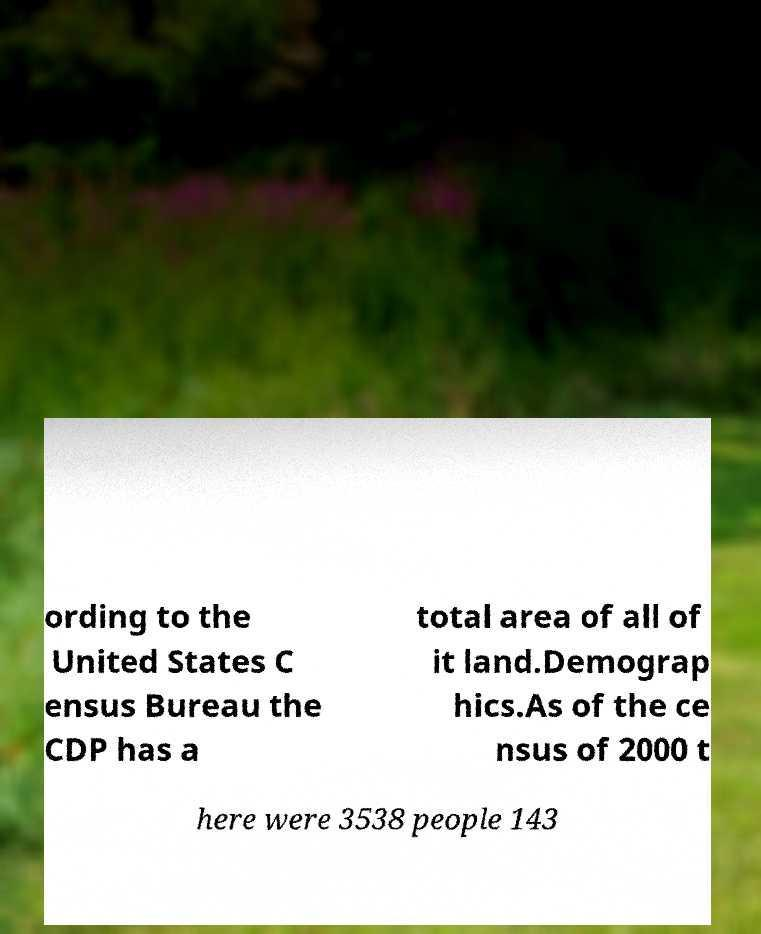Can you read and provide the text displayed in the image?This photo seems to have some interesting text. Can you extract and type it out for me? ording to the United States C ensus Bureau the CDP has a total area of all of it land.Demograp hics.As of the ce nsus of 2000 t here were 3538 people 143 